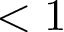<formula> <loc_0><loc_0><loc_500><loc_500>< 1</formula> 